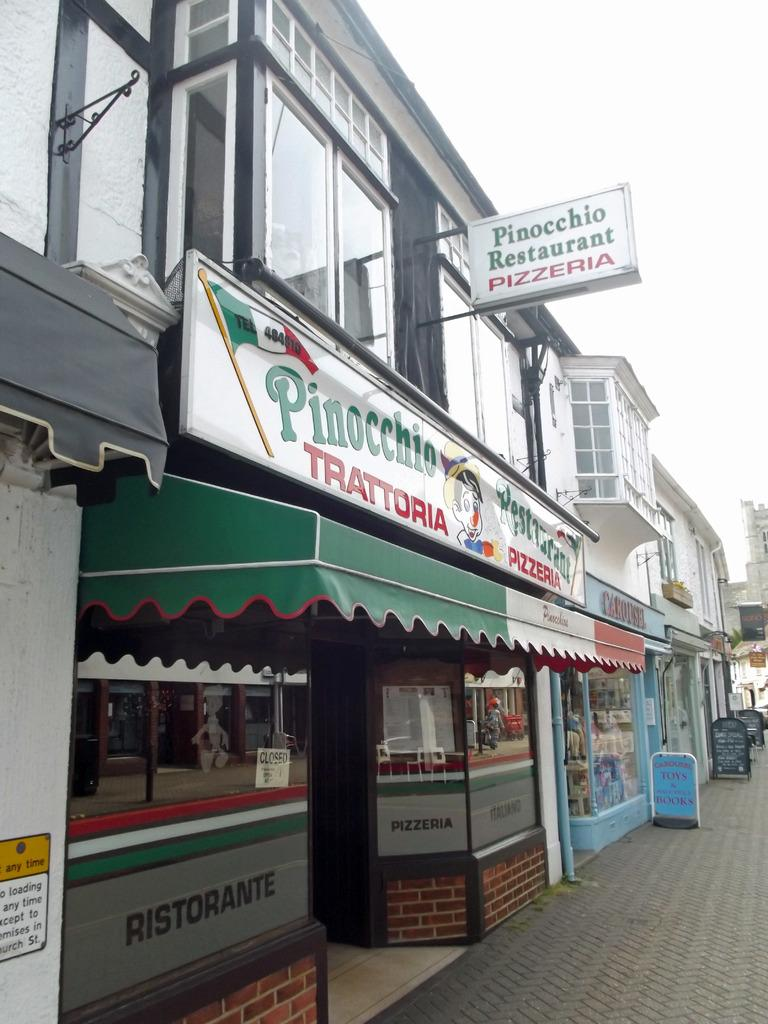<image>
Describe the image concisely. The restaurant with the green awning is called Pinocchio Restaurant 